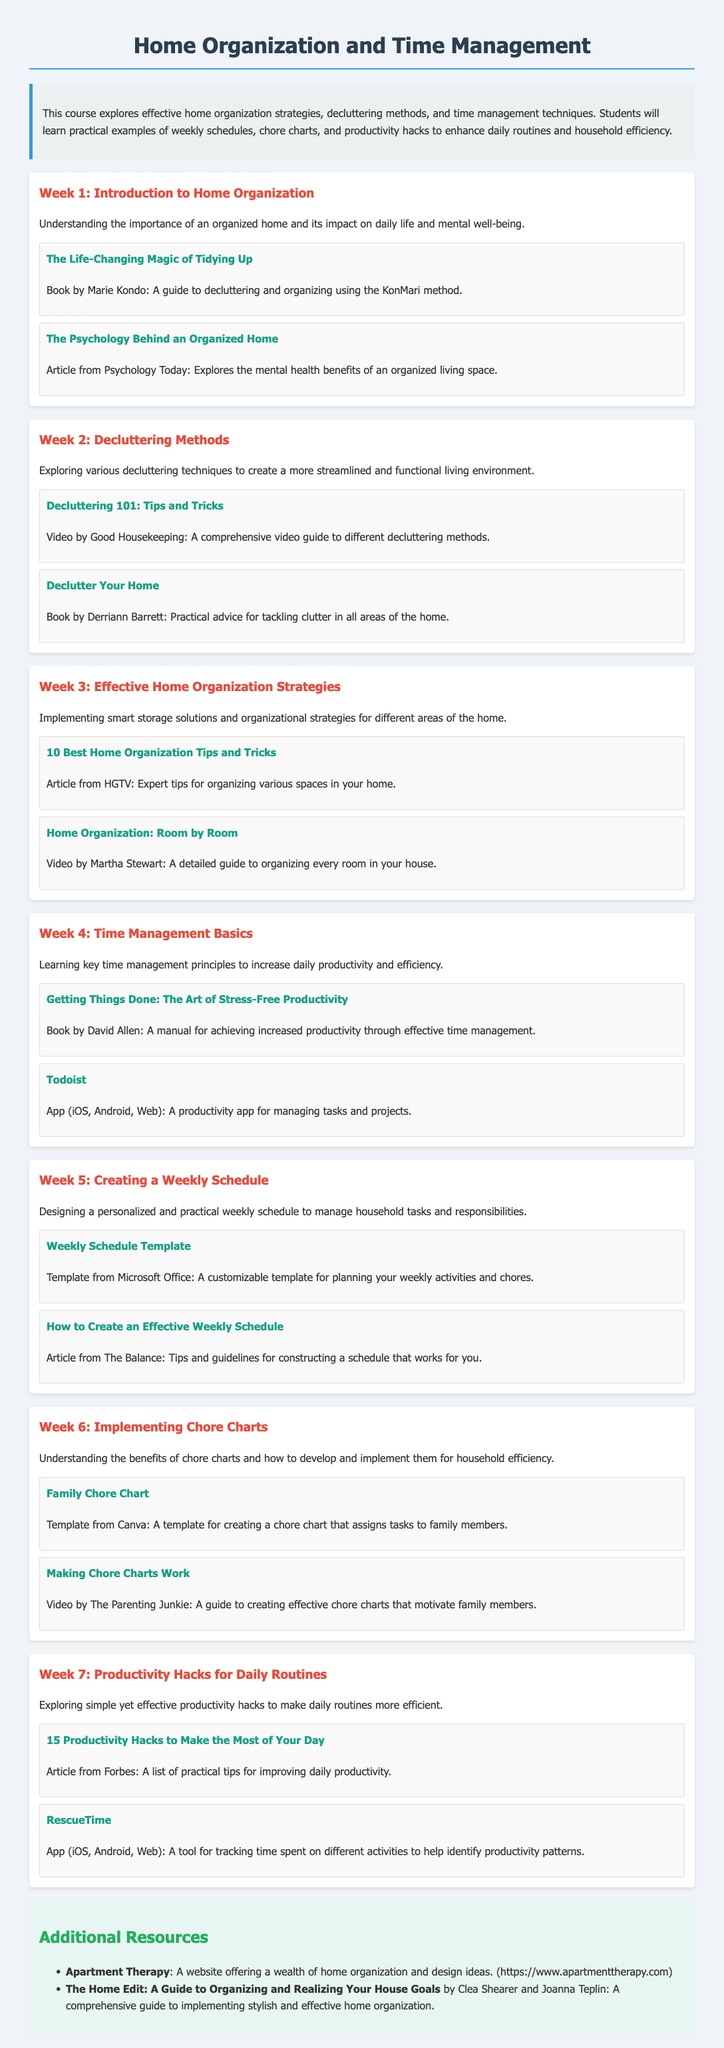What is the title of the syllabus? The title of the syllabus is explicitly stated as "Home Organization and Time Management."
Answer: Home Organization and Time Management Who is the author of "The Life-Changing Magic of Tidying Up"? The author of the book mentioned in Week 1 is Marie Kondo.
Answer: Marie Kondo What week focuses on time management basics? The document outlines that Week 4 is dedicated to time management basics.
Answer: Week 4 Which app helps in managing tasks as per Week 4? The app mentioned for managing tasks in Week 4 is Todoist.
Answer: Todoist What is one of the productivity hacks suggested in Week 7? The document states "15 Productivity Hacks to Make the Most of Your Day" as a suggested resource.
Answer: 15 Productivity Hacks to Make the Most of Your Day How many weeks are covered in the syllabus? The syllabus covers a total of 7 weeks.
Answer: 7 weeks What type of chart is implemented in Week 6? The syllabus mentions the implementation of chore charts in Week 6.
Answer: Chore charts What is the main focus of Week 5? Week 5 is focused on creating a weekly schedule.
Answer: Creating a weekly schedule 